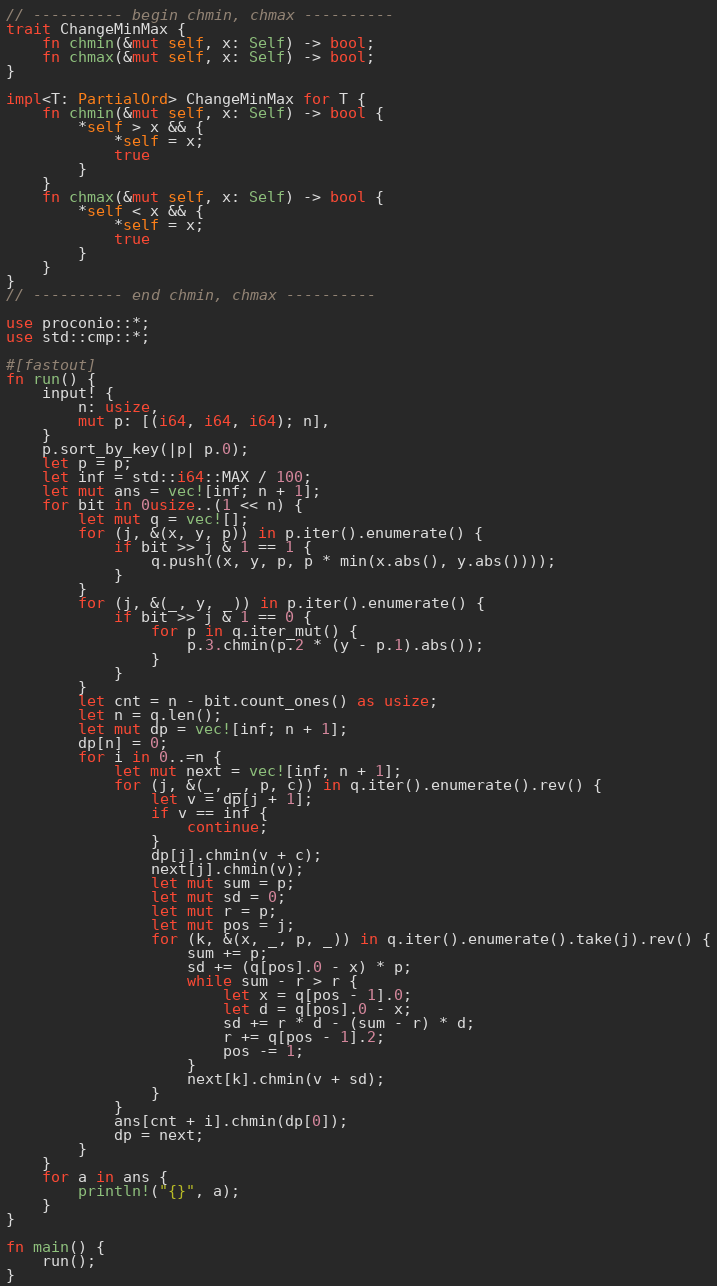Convert code to text. <code><loc_0><loc_0><loc_500><loc_500><_Rust_>// ---------- begin chmin, chmax ----------
trait ChangeMinMax {
    fn chmin(&mut self, x: Self) -> bool;
    fn chmax(&mut self, x: Self) -> bool;
}

impl<T: PartialOrd> ChangeMinMax for T {
    fn chmin(&mut self, x: Self) -> bool {
        *self > x && {
            *self = x;
            true
        }
    }
    fn chmax(&mut self, x: Self) -> bool {
        *self < x && {
            *self = x;
            true
        }
    }
}
// ---------- end chmin, chmax ----------

use proconio::*;
use std::cmp::*;

#[fastout]
fn run() {
    input! {
        n: usize,
        mut p: [(i64, i64, i64); n],
    }
    p.sort_by_key(|p| p.0);
    let p = p;
    let inf = std::i64::MAX / 100;
    let mut ans = vec![inf; n + 1];
    for bit in 0usize..(1 << n) {
        let mut q = vec![];
        for (j, &(x, y, p)) in p.iter().enumerate() {
            if bit >> j & 1 == 1 {
                q.push((x, y, p, p * min(x.abs(), y.abs())));
            }
        }
        for (j, &(_, y, _)) in p.iter().enumerate() {
            if bit >> j & 1 == 0 {
                for p in q.iter_mut() {
                    p.3.chmin(p.2 * (y - p.1).abs());
                }
            }
        }
        let cnt = n - bit.count_ones() as usize;
        let n = q.len();
        let mut dp = vec![inf; n + 1];
        dp[n] = 0;
        for i in 0..=n {
            let mut next = vec![inf; n + 1];
            for (j, &(_, _, p, c)) in q.iter().enumerate().rev() {
                let v = dp[j + 1];
                if v == inf {
                    continue;
                }
                dp[j].chmin(v + c);
                next[j].chmin(v);
                let mut sum = p;
                let mut sd = 0;
                let mut r = p;
                let mut pos = j;
                for (k, &(x, _, p, _)) in q.iter().enumerate().take(j).rev() {
                    sum += p;
                    sd += (q[pos].0 - x) * p;
                    while sum - r > r {
                        let x = q[pos - 1].0;
                        let d = q[pos].0 - x;
                        sd += r * d - (sum - r) * d;
                        r += q[pos - 1].2;
                        pos -= 1;
                    }
                    next[k].chmin(v + sd);
                }
            }
            ans[cnt + i].chmin(dp[0]);
            dp = next;
        }
    }
    for a in ans {
        println!("{}", a);
    }
}

fn main() {
    run();
}
</code> 